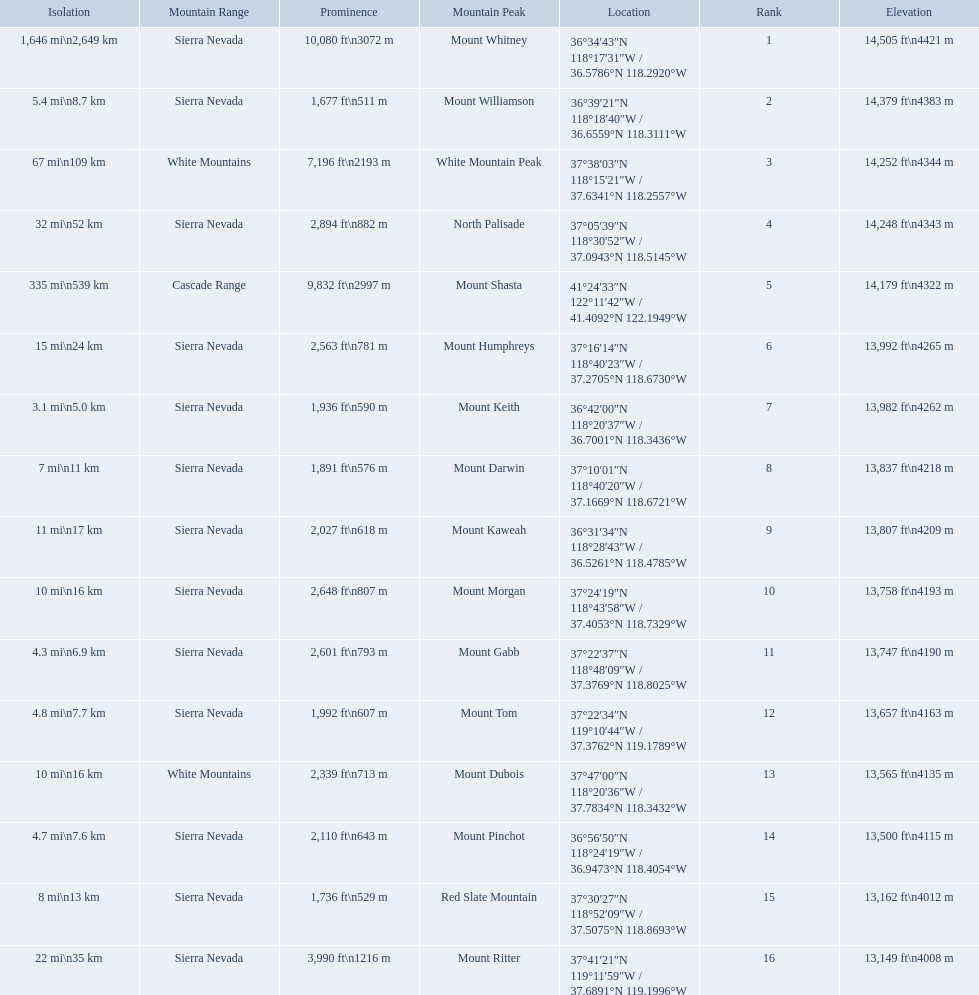What are the listed elevations? 14,505 ft\n4421 m, 14,379 ft\n4383 m, 14,252 ft\n4344 m, 14,248 ft\n4343 m, 14,179 ft\n4322 m, 13,992 ft\n4265 m, 13,982 ft\n4262 m, 13,837 ft\n4218 m, 13,807 ft\n4209 m, 13,758 ft\n4193 m, 13,747 ft\n4190 m, 13,657 ft\n4163 m, 13,565 ft\n4135 m, 13,500 ft\n4115 m, 13,162 ft\n4012 m, 13,149 ft\n4008 m. Which of those is 13,149 ft or below? 13,149 ft\n4008 m. To what mountain peak does that value correspond? Mount Ritter. What are the heights of the californian mountain peaks? 14,505 ft\n4421 m, 14,379 ft\n4383 m, 14,252 ft\n4344 m, 14,248 ft\n4343 m, 14,179 ft\n4322 m, 13,992 ft\n4265 m, 13,982 ft\n4262 m, 13,837 ft\n4218 m, 13,807 ft\n4209 m, 13,758 ft\n4193 m, 13,747 ft\n4190 m, 13,657 ft\n4163 m, 13,565 ft\n4135 m, 13,500 ft\n4115 m, 13,162 ft\n4012 m, 13,149 ft\n4008 m. What elevation is 13,149 ft or less? 13,149 ft\n4008 m. What mountain peak is at this elevation? Mount Ritter. 